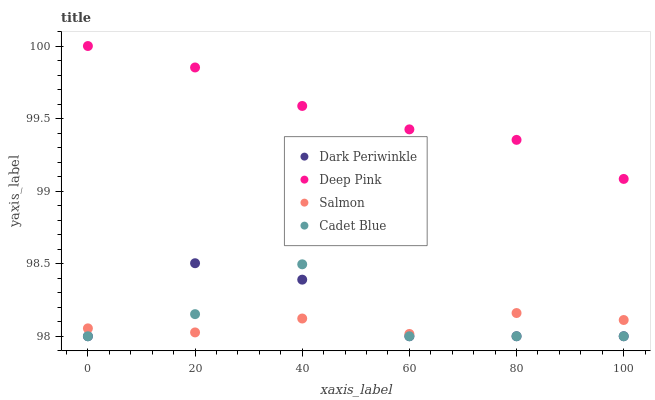Does Salmon have the minimum area under the curve?
Answer yes or no. Yes. Does Deep Pink have the maximum area under the curve?
Answer yes or no. Yes. Does Deep Pink have the minimum area under the curve?
Answer yes or no. No. Does Salmon have the maximum area under the curve?
Answer yes or no. No. Is Deep Pink the smoothest?
Answer yes or no. Yes. Is Cadet Blue the roughest?
Answer yes or no. Yes. Is Salmon the smoothest?
Answer yes or no. No. Is Salmon the roughest?
Answer yes or no. No. Does Cadet Blue have the lowest value?
Answer yes or no. Yes. Does Salmon have the lowest value?
Answer yes or no. No. Does Deep Pink have the highest value?
Answer yes or no. Yes. Does Salmon have the highest value?
Answer yes or no. No. Is Cadet Blue less than Deep Pink?
Answer yes or no. Yes. Is Deep Pink greater than Dark Periwinkle?
Answer yes or no. Yes. Does Cadet Blue intersect Dark Periwinkle?
Answer yes or no. Yes. Is Cadet Blue less than Dark Periwinkle?
Answer yes or no. No. Is Cadet Blue greater than Dark Periwinkle?
Answer yes or no. No. Does Cadet Blue intersect Deep Pink?
Answer yes or no. No. 